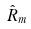<formula> <loc_0><loc_0><loc_500><loc_500>\hat { R } _ { m }</formula> 